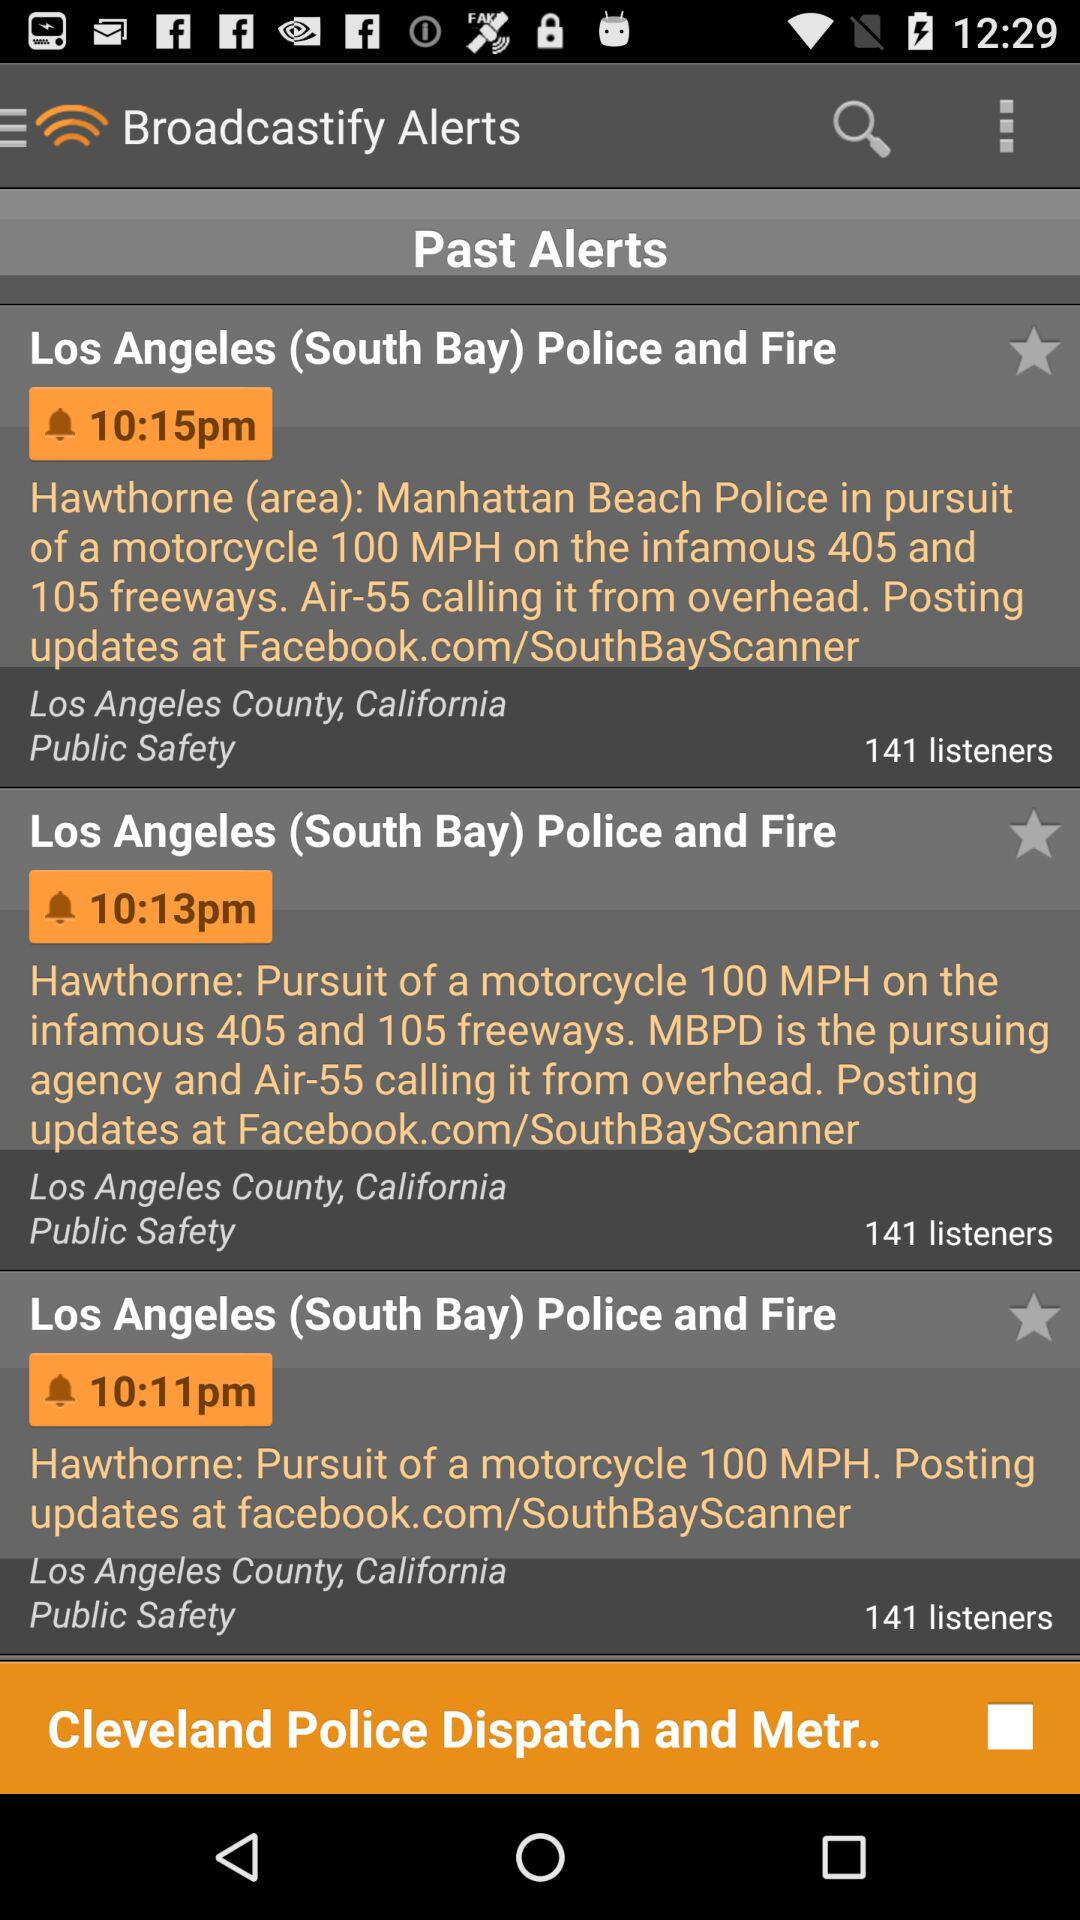What is the headline of the alert broadcast at 10:13 p.m.? The headline of the alert broadcast is "Los Angeles (South Bay) Police and Fire". 